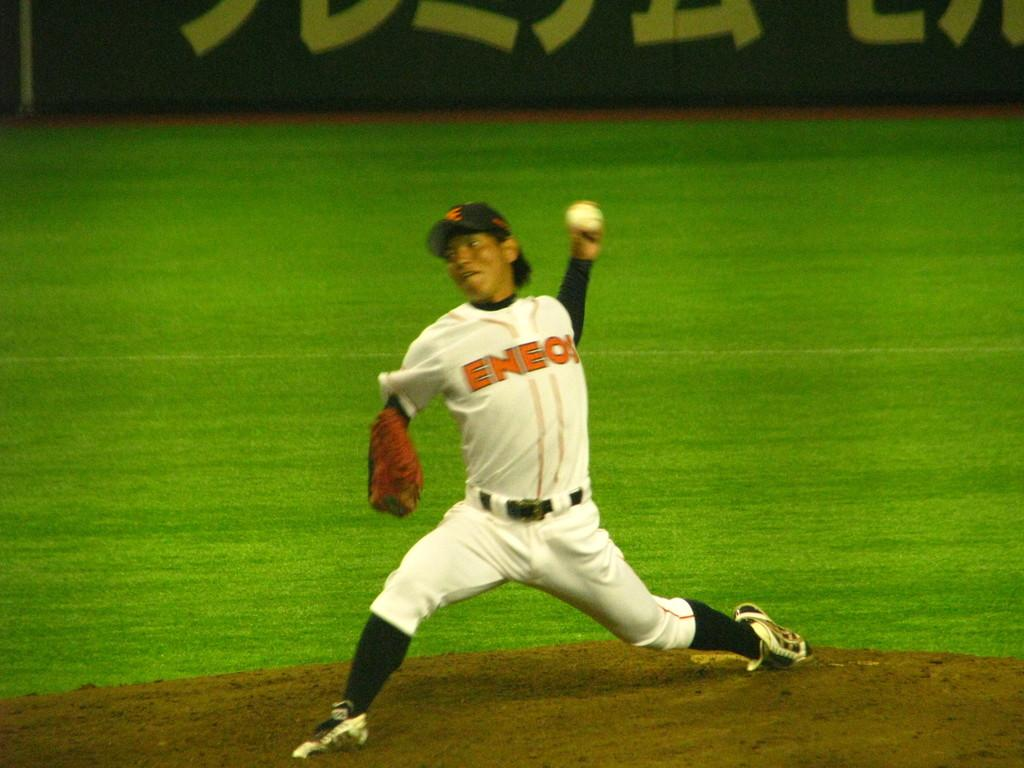<image>
Describe the image concisely. A baseball player with the word eneo is on his chest. 